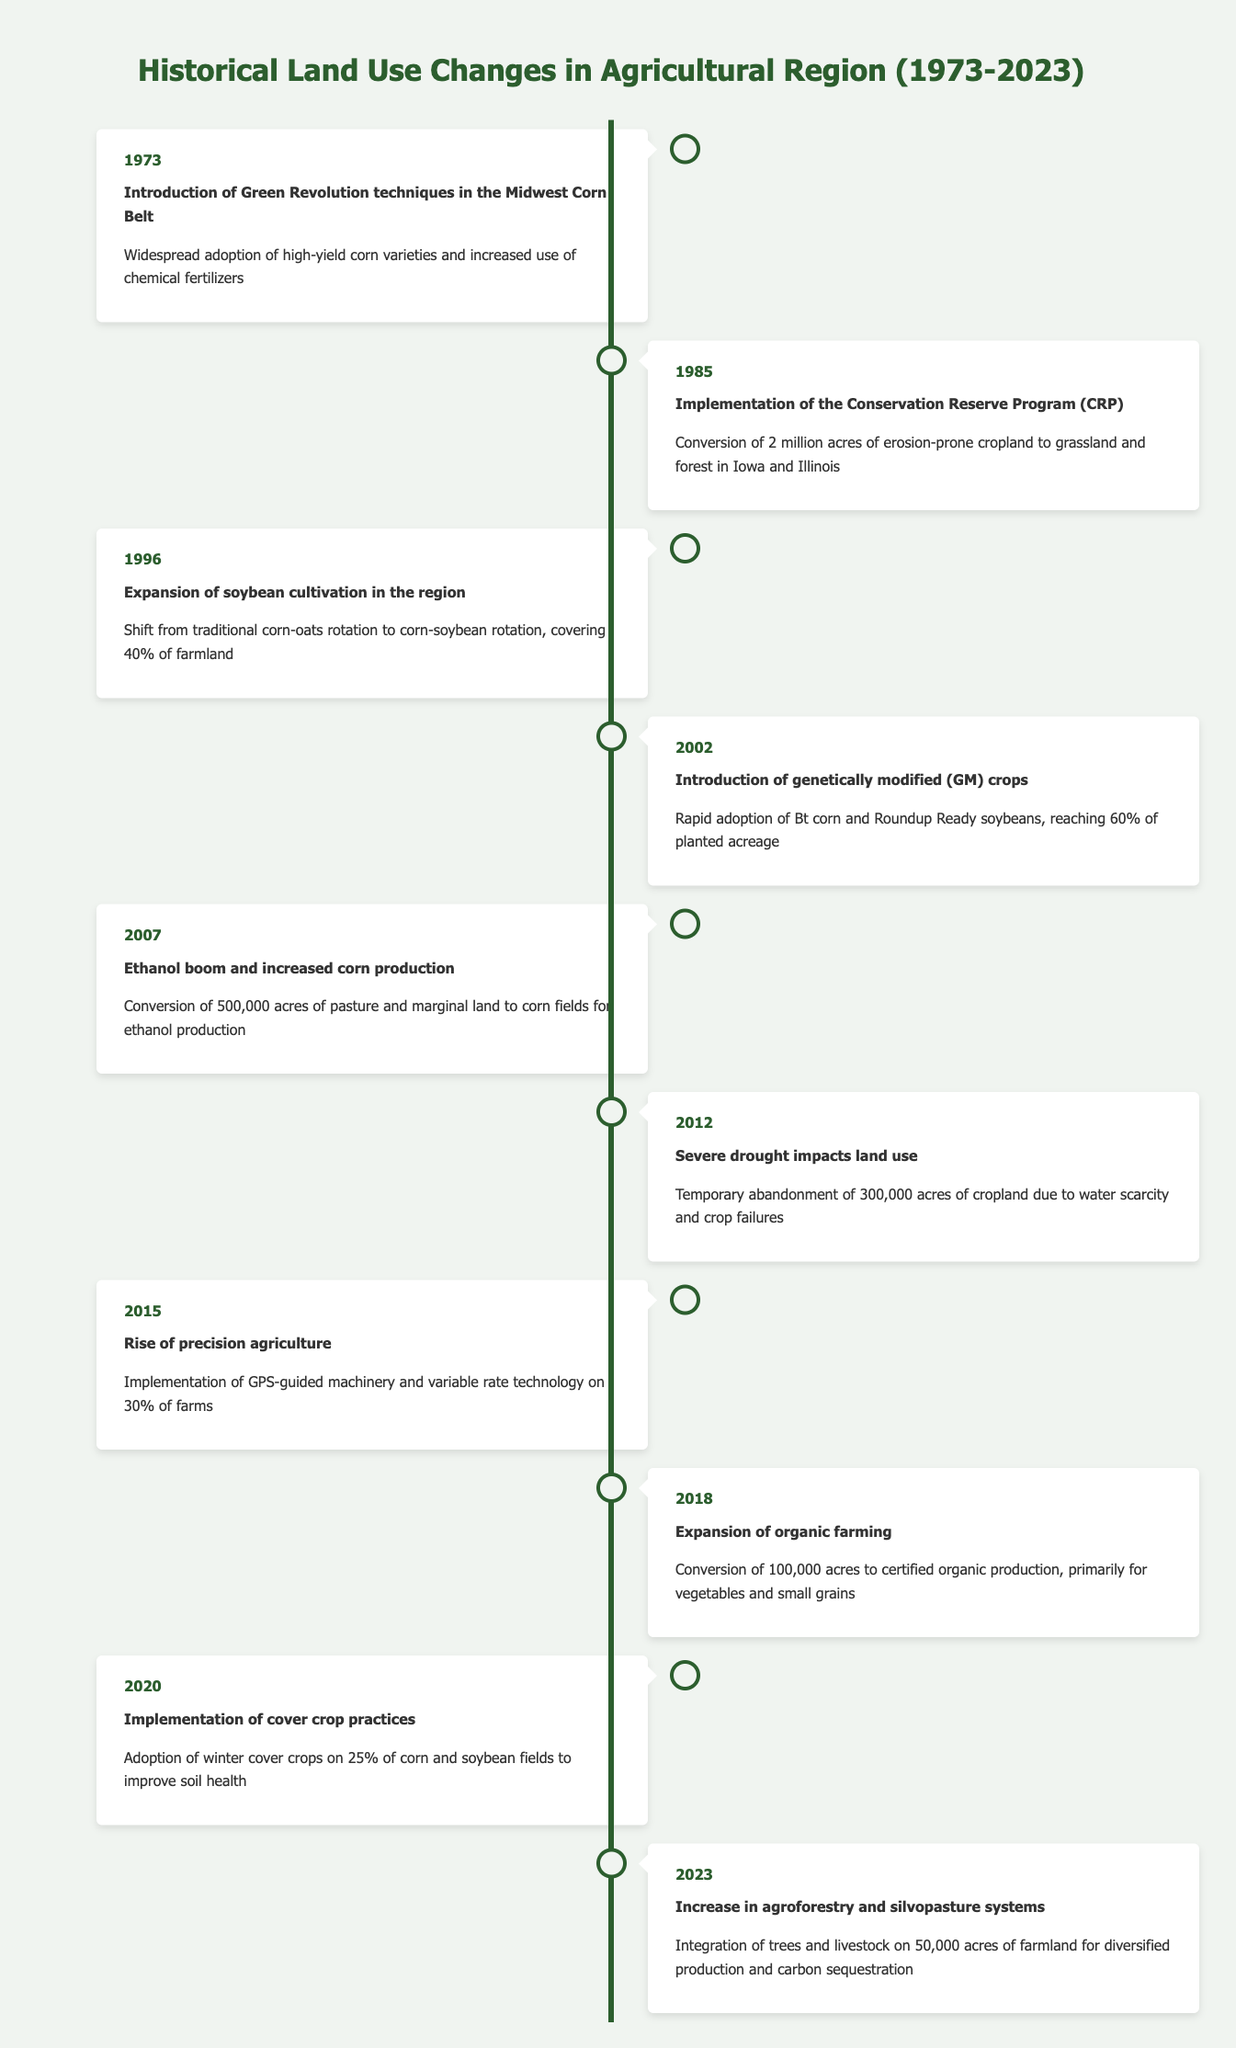What significant agricultural technique was introduced in 1973? The data shows that in 1973, the introduction of Green Revolution techniques occurred, marked by the widespread adoption of high-yield corn varieties and increased use of chemical fertilizers.
Answer: Green Revolution techniques How many acres were converted to grassland and forest in 1985? According to the table, the implementation of the Conservation Reserve Program in 1985 led to the conversion of 2 million acres of erosion-prone cropland to grassland and forest.
Answer: 2 million acres What crop rotation shift was observed in 1996? The timeline states that in 1996, the shift from traditional corn-oats rotation to corn-soybean rotation was noted, covering 40% of farmland in the region.
Answer: Corn-oat to corn-soybean rotation True or False: Genetically modified crops reached 60% of planted acreage by 2002. The data confirms that by 2002, the introduction of genetically modified crops had indeed led to their rapid adoption, reaching 60% of planted acreage.
Answer: True What was the impact of the severe drought in 2012 on cropland? The table indicates that in 2012, due to severe drought, there was a temporary abandonment of 300,000 acres of cropland as a direct result of water scarcity and crop failures.
Answer: 300,000 acres How many acres were converted for ethanol production in 2007? In 2007, the timeline notes that 500,000 acres of pasture and marginal land were converted to corn fields specifically for ethanol production.
Answer: 500,000 acres What is the difference in acres between organic farming expansion in 2018 and agroforestry systems in 2023? The table shows that 100,000 acres were converted to certified organic production in 2018, while in 2023 the integration of trees and livestock on 50,000 acres occurred. The difference is 100,000 - 50,000 = 50,000 acres.
Answer: 50,000 acres What percentage of farms implemented precision agriculture by 2015? By 2015, the data states that 30% of farms had implemented GPS-guided machinery and variable rate technology, indicating the rise of precision agriculture.
Answer: 30% Was there an increase in agroforestry practices introduced after 2018? The timelines indicate that the increase in agroforestry and silvopasture systems was noted in 2023, which suggests a new practice introduced after the expansion of organic farming in 2018. Therefore, the statement is assessed as true.
Answer: True 